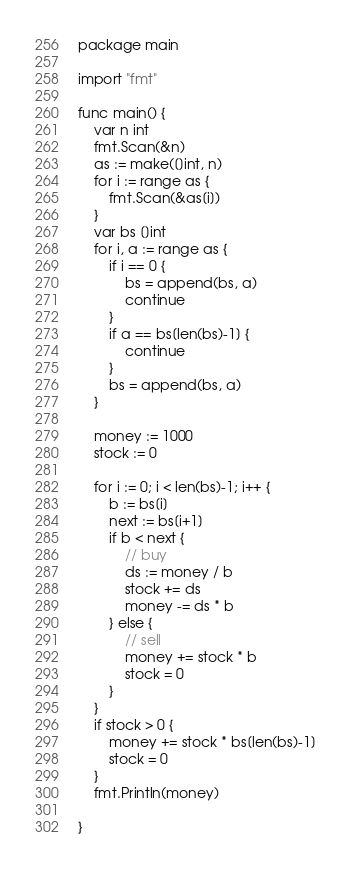<code> <loc_0><loc_0><loc_500><loc_500><_Go_>package main

import "fmt"

func main() {
	var n int
	fmt.Scan(&n)
	as := make([]int, n)
	for i := range as {
		fmt.Scan(&as[i])
	}
	var bs []int
	for i, a := range as {
		if i == 0 {
			bs = append(bs, a)
			continue
		}
		if a == bs[len(bs)-1] {
			continue
		}
		bs = append(bs, a)
	}

	money := 1000
	stock := 0

	for i := 0; i < len(bs)-1; i++ {
		b := bs[i]
		next := bs[i+1]
		if b < next {
			// buy
			ds := money / b
			stock += ds
			money -= ds * b
		} else {
			// sell
			money += stock * b
			stock = 0
		}
	}
	if stock > 0 {
		money += stock * bs[len(bs)-1]
		stock = 0
	}
	fmt.Println(money)

}
</code> 